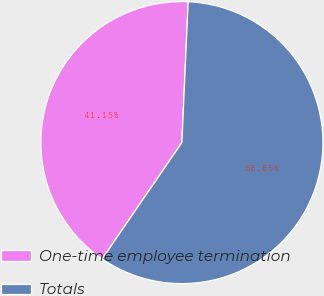<chart> <loc_0><loc_0><loc_500><loc_500><pie_chart><fcel>One-time employee termination<fcel>Totals<nl><fcel>41.15%<fcel>58.85%<nl></chart> 